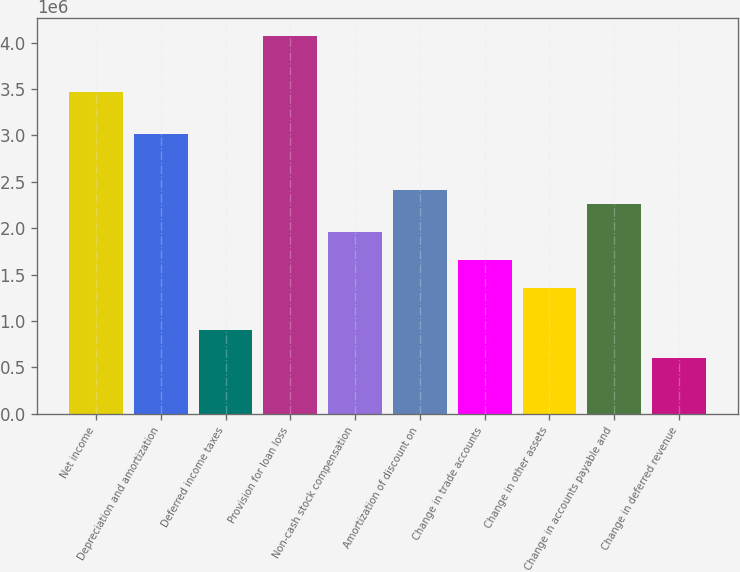<chart> <loc_0><loc_0><loc_500><loc_500><bar_chart><fcel>Net income<fcel>Depreciation and amortization<fcel>Deferred income taxes<fcel>Provision for loan loss<fcel>Non-cash stock compensation<fcel>Amortization of discount on<fcel>Change in trade accounts<fcel>Change in other assets<fcel>Change in accounts payable and<fcel>Change in deferred revenue<nl><fcel>3.46341e+06<fcel>3.01193e+06<fcel>905027<fcel>4.06539e+06<fcel>1.95848e+06<fcel>2.40996e+06<fcel>1.65749e+06<fcel>1.35651e+06<fcel>2.25947e+06<fcel>604040<nl></chart> 